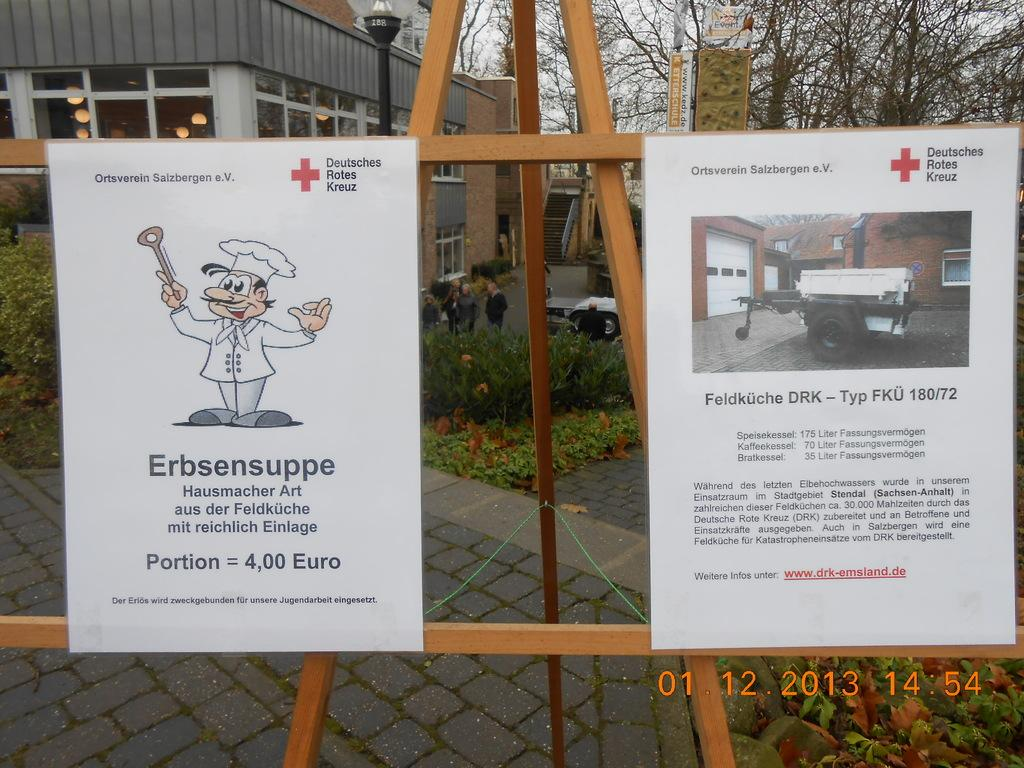What is the main object in the foreground of the image? There is a wooden stand with posters in the image. What can be seen in the background of the image? There are trees, plants, and a building with lights in the background of the image. Can you describe the wooden stand in the image? The wooden stand is holding posters. Is there any indication of the image's origin or ownership? Yes, there is a watermark on the image. What type of acoustics can be heard in the image? There is no sound or indication of acoustics in the image; it is a still photograph. Can you see a baby in the image? There is no baby present in the image. 